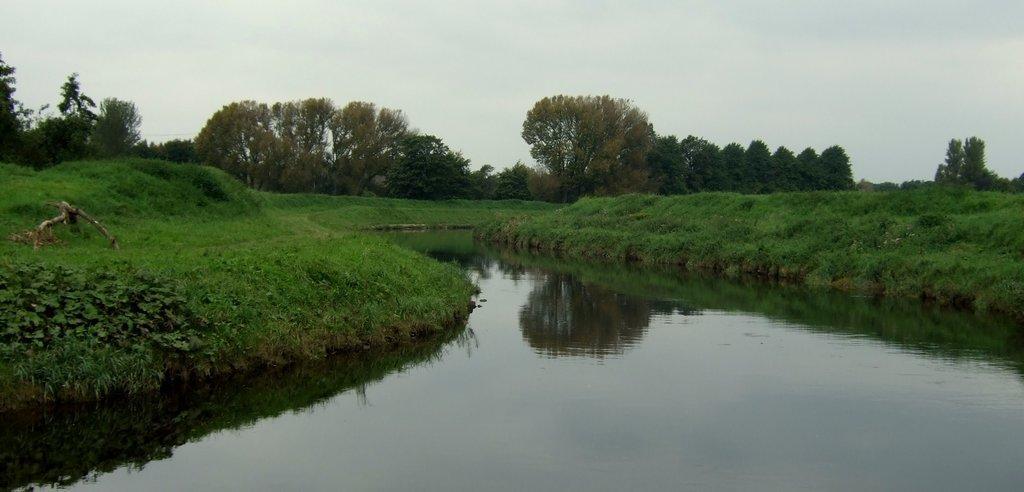In one or two sentences, can you explain what this image depicts? In this picture I can see the water in the center and I can see the grass on both the sides. In the background I can see the trees and the sky. 